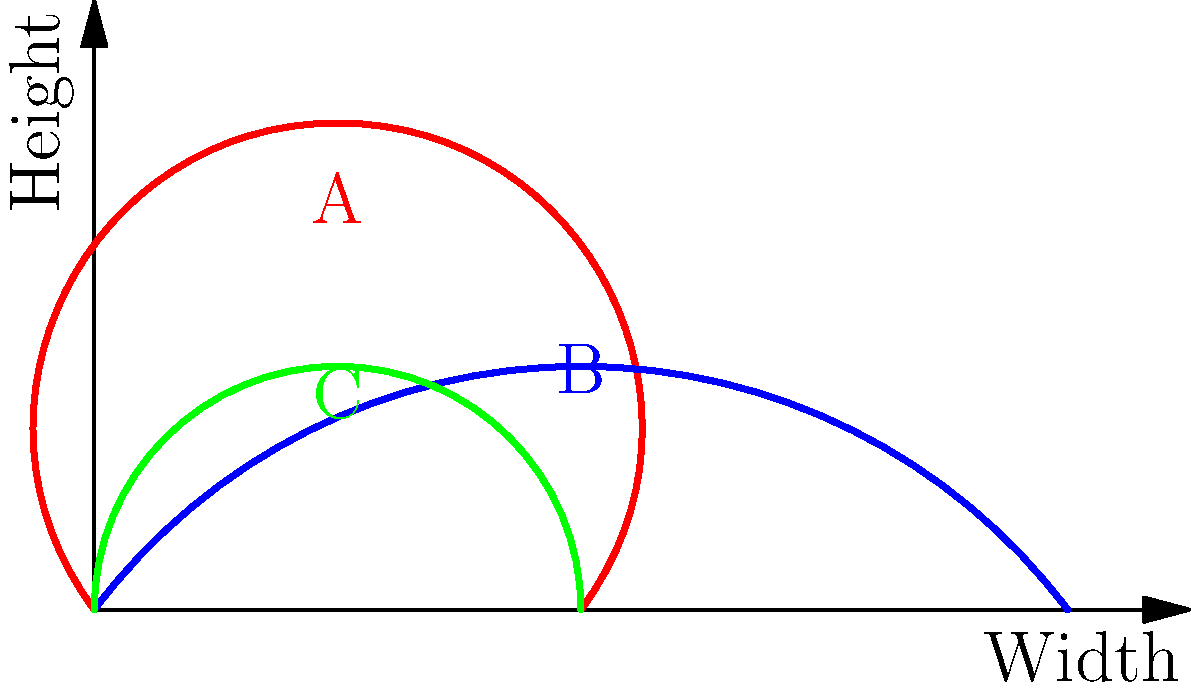As a noodle shop owner, you're considering different bowl shapes for your famous Biang Biang Noodles. The diagram shows three bowl profiles: A (red), B (blue), and C (green). Which bowl shape would likely retain heat the best, assuming they all have the same volume? Explain your reasoning using the concept of surface area to volume ratio. To determine which bowl shape would retain heat the best, we need to consider the surface area to volume ratio. A lower ratio indicates better heat retention. Let's analyze each bowl shape:

1. Bowl A (red): This bowl is tall and narrow.
   - It has a relatively large surface area due to its height.
   - Its volume is smaller compared to its surface area.
   - This results in a higher surface area to volume ratio.

2. Bowl B (blue): This bowl is wide and shallow.
   - It has a large surface area, especially at the top.
   - Its volume is spread out, leading to more exposure to air.
   - This also results in a higher surface area to volume ratio.

3. Bowl C (green): This bowl has a more balanced shape.
   - Its height and width are more proportional.
   - It has a smaller surface area compared to the other two shapes.
   - Its volume is more compact.
   - This results in a lower surface area to volume ratio.

The surface area to volume ratio is crucial for heat retention because:
   $$\text{Heat loss rate} \propto \frac{\text{Surface Area}}{\text{Volume}}$$

A lower ratio means less surface area for the same volume, which reduces heat loss to the environment. 

Therefore, bowl C (green) would likely retain heat the best among the three options. Its more balanced shape minimizes the surface area exposed to the air while maintaining the same volume, resulting in the lowest surface area to volume ratio.
Answer: Bowl C (green) 